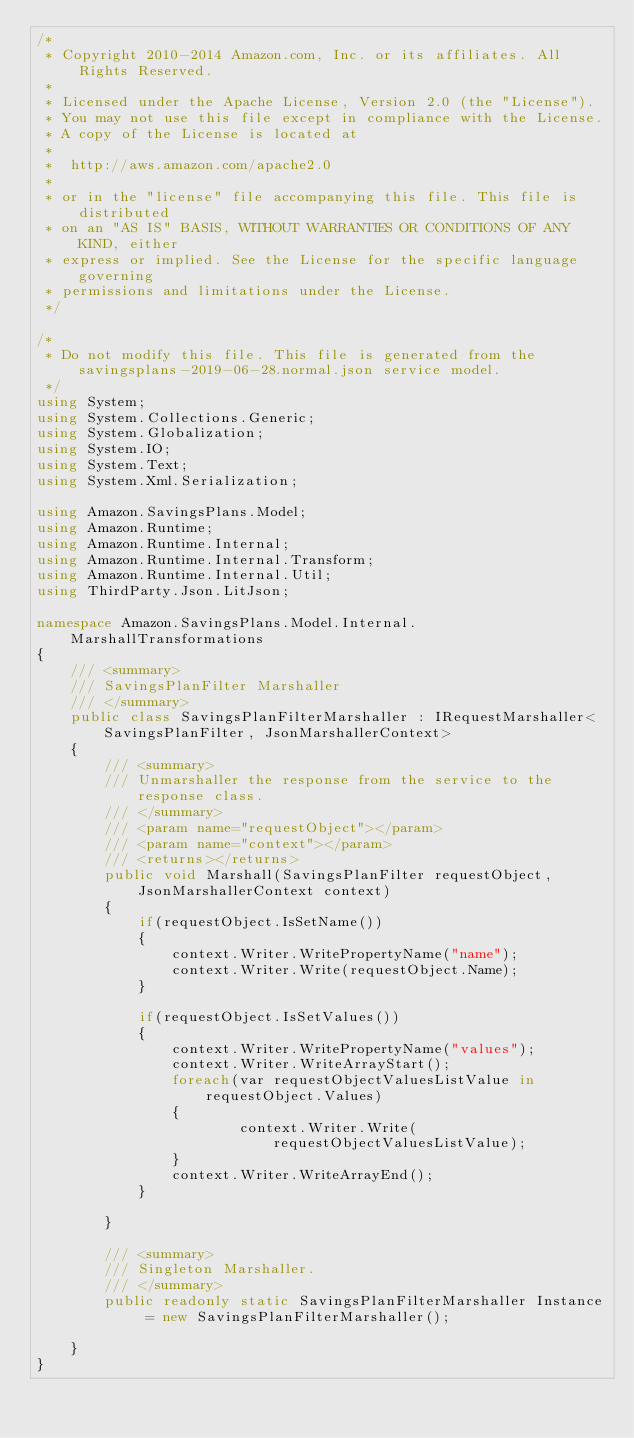Convert code to text. <code><loc_0><loc_0><loc_500><loc_500><_C#_>/*
 * Copyright 2010-2014 Amazon.com, Inc. or its affiliates. All Rights Reserved.
 * 
 * Licensed under the Apache License, Version 2.0 (the "License").
 * You may not use this file except in compliance with the License.
 * A copy of the License is located at
 * 
 *  http://aws.amazon.com/apache2.0
 * 
 * or in the "license" file accompanying this file. This file is distributed
 * on an "AS IS" BASIS, WITHOUT WARRANTIES OR CONDITIONS OF ANY KIND, either
 * express or implied. See the License for the specific language governing
 * permissions and limitations under the License.
 */

/*
 * Do not modify this file. This file is generated from the savingsplans-2019-06-28.normal.json service model.
 */
using System;
using System.Collections.Generic;
using System.Globalization;
using System.IO;
using System.Text;
using System.Xml.Serialization;

using Amazon.SavingsPlans.Model;
using Amazon.Runtime;
using Amazon.Runtime.Internal;
using Amazon.Runtime.Internal.Transform;
using Amazon.Runtime.Internal.Util;
using ThirdParty.Json.LitJson;

namespace Amazon.SavingsPlans.Model.Internal.MarshallTransformations
{
    /// <summary>
    /// SavingsPlanFilter Marshaller
    /// </summary>       
    public class SavingsPlanFilterMarshaller : IRequestMarshaller<SavingsPlanFilter, JsonMarshallerContext> 
    {
        /// <summary>
        /// Unmarshaller the response from the service to the response class.
        /// </summary>  
        /// <param name="requestObject"></param>
        /// <param name="context"></param>
        /// <returns></returns>
        public void Marshall(SavingsPlanFilter requestObject, JsonMarshallerContext context)
        {
            if(requestObject.IsSetName())
            {
                context.Writer.WritePropertyName("name");
                context.Writer.Write(requestObject.Name);
            }

            if(requestObject.IsSetValues())
            {
                context.Writer.WritePropertyName("values");
                context.Writer.WriteArrayStart();
                foreach(var requestObjectValuesListValue in requestObject.Values)
                {
                        context.Writer.Write(requestObjectValuesListValue);
                }
                context.Writer.WriteArrayEnd();
            }

        }

        /// <summary>
        /// Singleton Marshaller.
        /// </summary>  
        public readonly static SavingsPlanFilterMarshaller Instance = new SavingsPlanFilterMarshaller();

    }
}</code> 